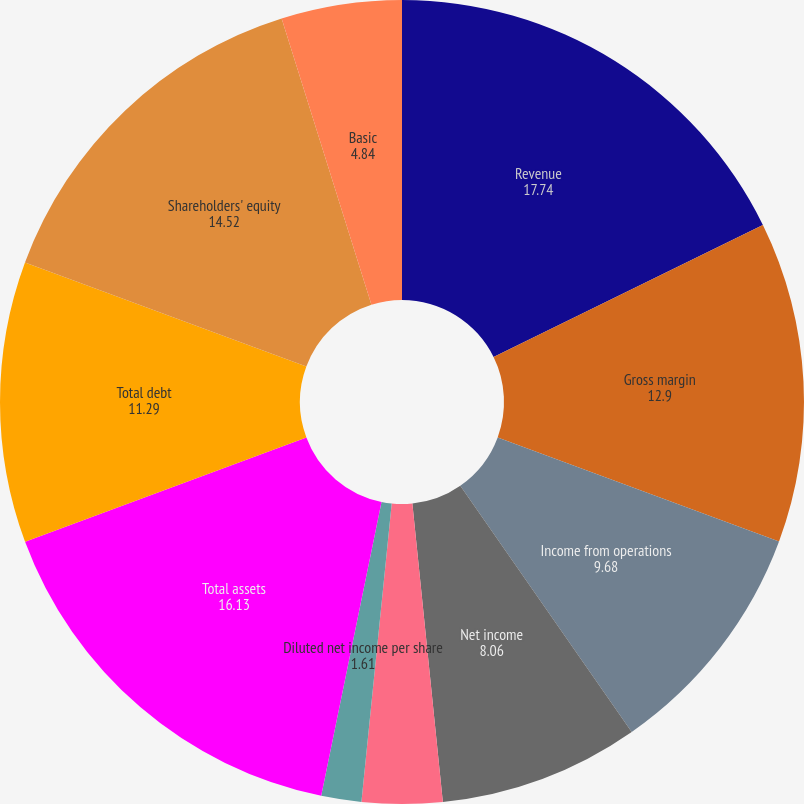<chart> <loc_0><loc_0><loc_500><loc_500><pie_chart><fcel>Revenue<fcel>Gross margin<fcel>Income from operations<fcel>Net income<fcel>Basic net income per share<fcel>Diluted net income per share<fcel>Total assets<fcel>Total debt<fcel>Shareholders' equity<fcel>Basic<nl><fcel>17.74%<fcel>12.9%<fcel>9.68%<fcel>8.06%<fcel>3.23%<fcel>1.61%<fcel>16.13%<fcel>11.29%<fcel>14.52%<fcel>4.84%<nl></chart> 